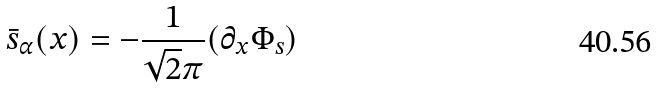Convert formula to latex. <formula><loc_0><loc_0><loc_500><loc_500>\bar { s } _ { \alpha } ( x ) = - \frac { 1 } { \sqrt { 2 } \pi } ( \partial _ { x } \Phi _ { s } )</formula> 